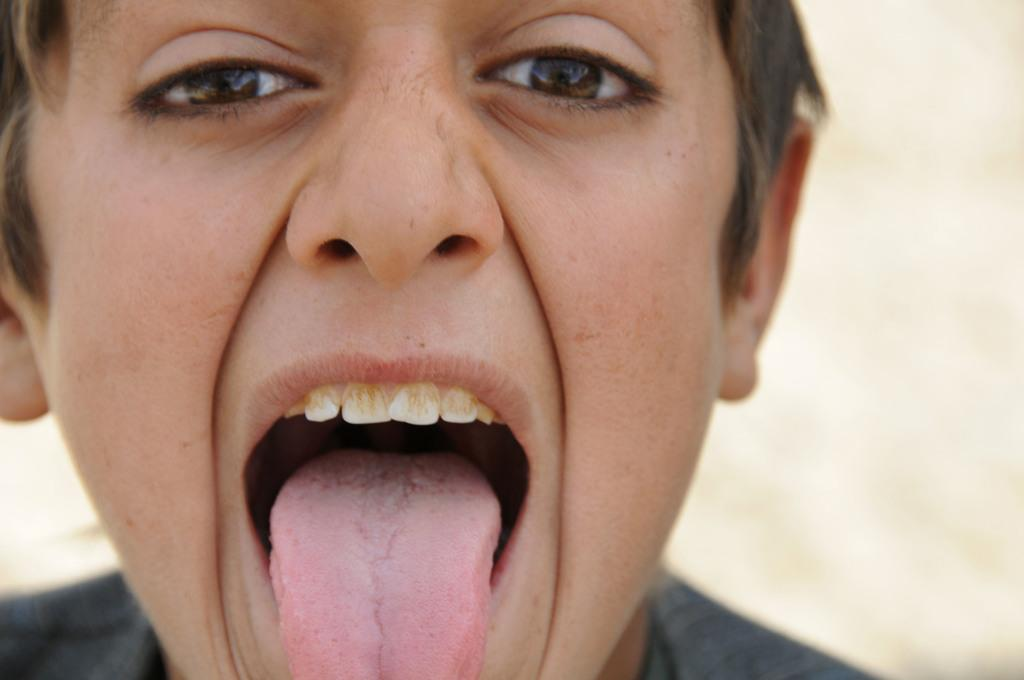Who or what is the main subject of the image? There is a person in the image. Can you describe the background of the image? The background of the image is blurry. What type of legal advice is the scarecrow providing in the image? There is no scarecrow or legal advice present in the image; it features a person with a blurry background. 